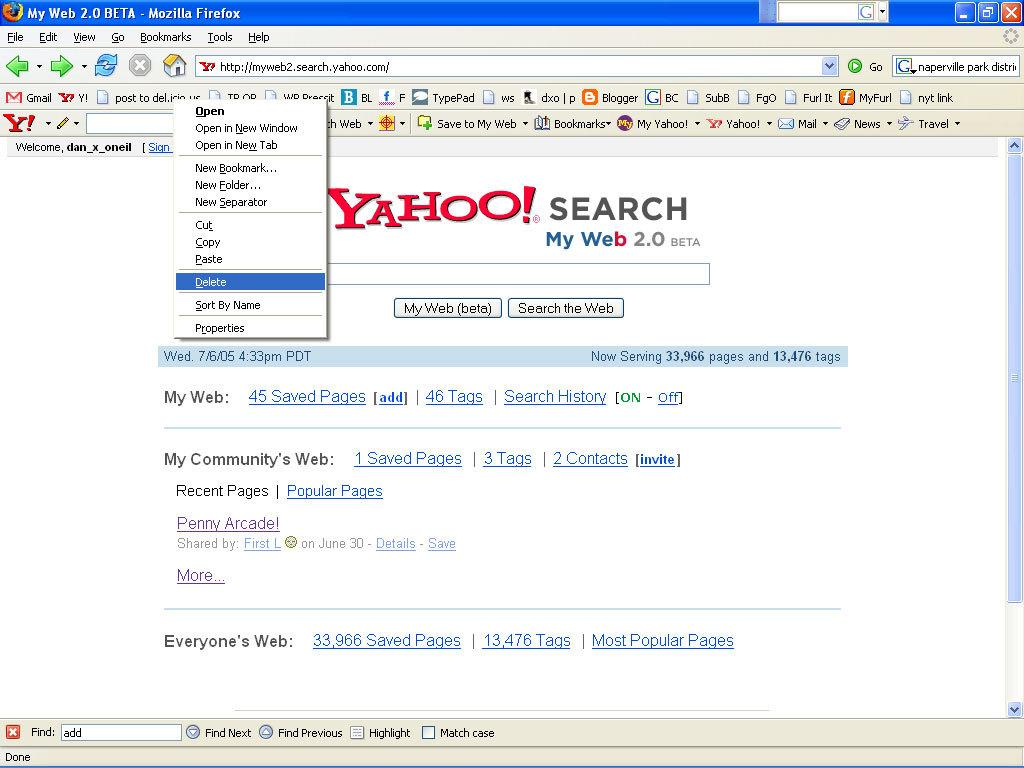<image>
Summarize the visual content of the image. Screen showing Yahoo Search and is in a 2.0 Beta. 